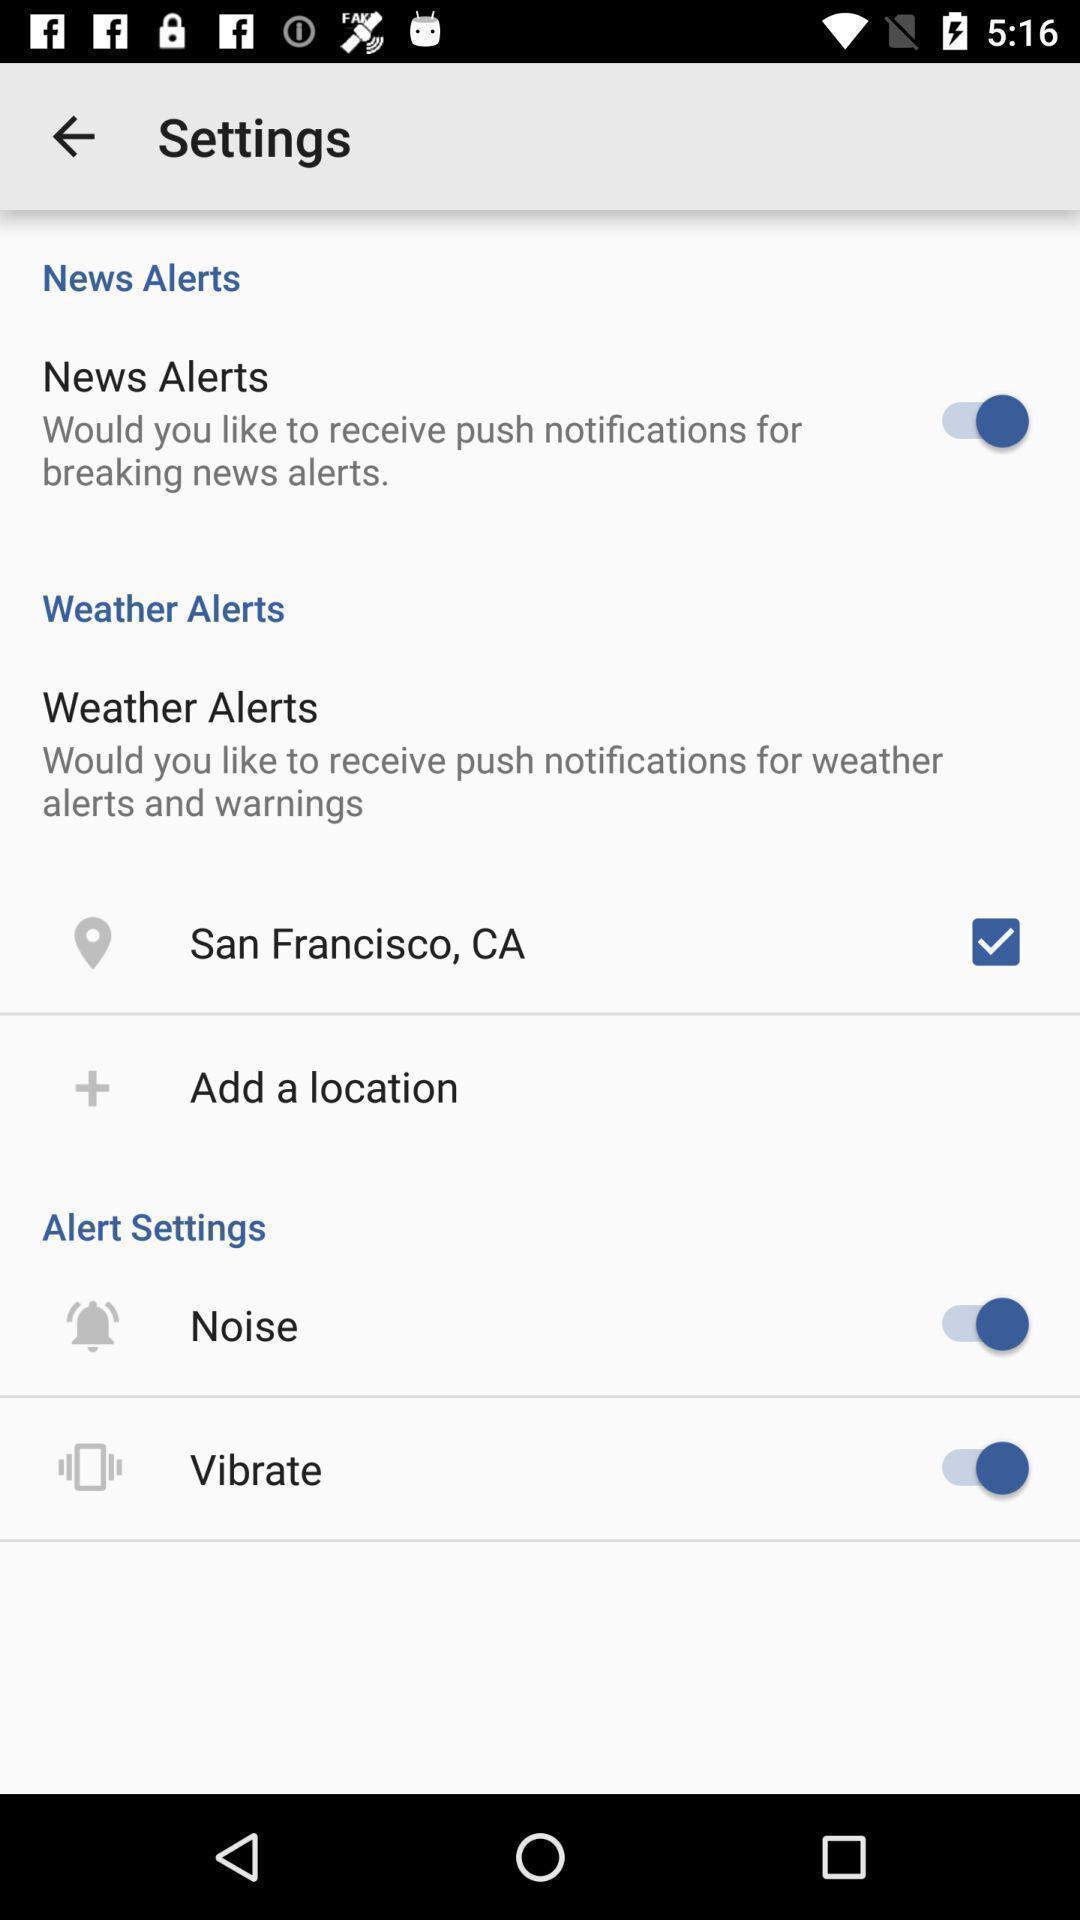Summarize the information in this screenshot. Settings page with various option for the weather news app. 